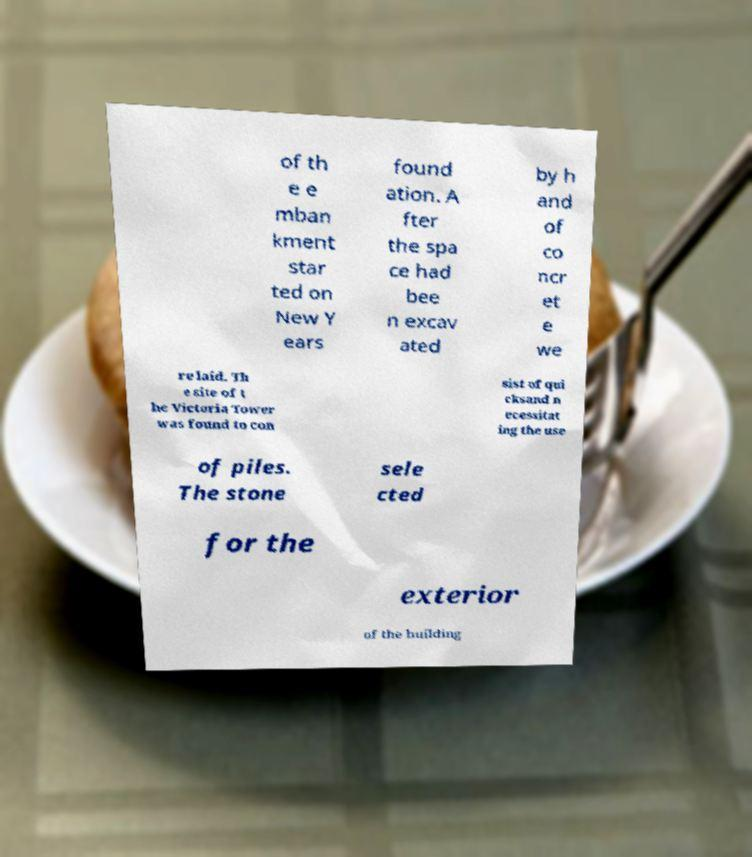Please identify and transcribe the text found in this image. of th e e mban kment star ted on New Y ears found ation. A fter the spa ce had bee n excav ated by h and of co ncr et e we re laid. Th e site of t he Victoria Tower was found to con sist of qui cksand n ecessitat ing the use of piles. The stone sele cted for the exterior of the building 